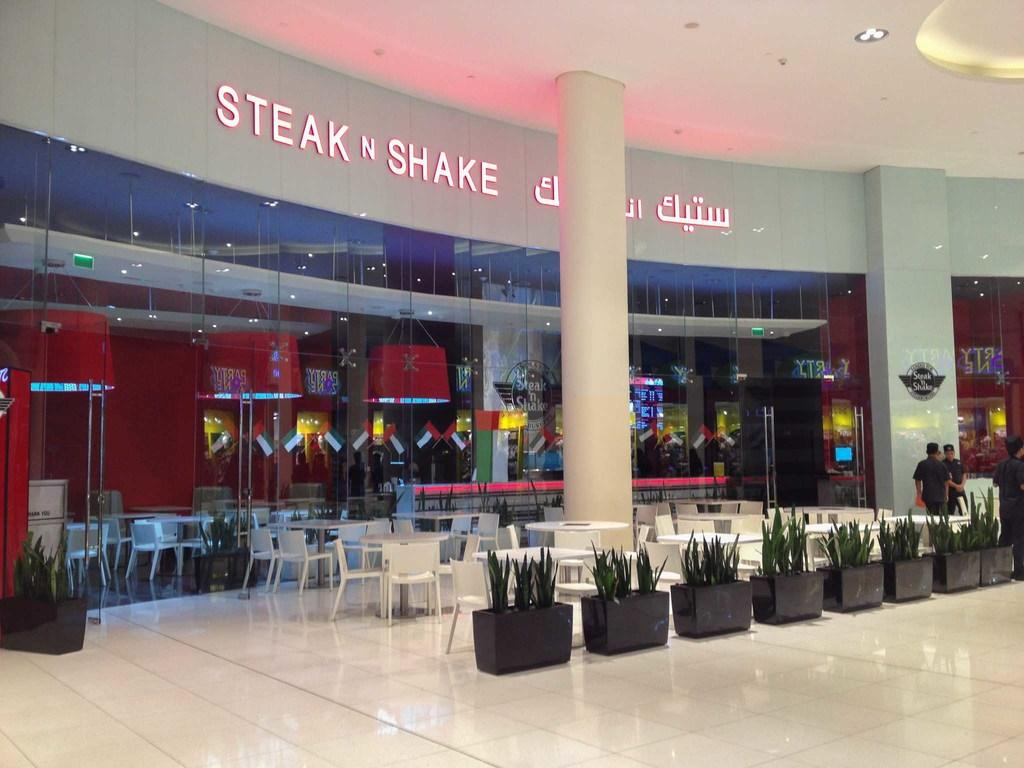<image>
Summarize the visual content of the image. A Steak N Shake in a mall written in English and another language. 